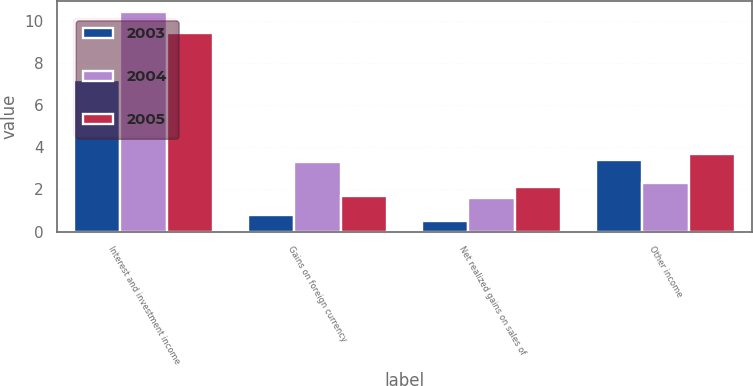Convert chart. <chart><loc_0><loc_0><loc_500><loc_500><stacked_bar_chart><ecel><fcel>Interest and investment income<fcel>Gains on foreign currency<fcel>Net realized gains on sales of<fcel>Other income<nl><fcel>2003<fcel>7.2<fcel>0.8<fcel>0.5<fcel>3.4<nl><fcel>2004<fcel>10.4<fcel>3.3<fcel>1.6<fcel>2.3<nl><fcel>2005<fcel>9.4<fcel>1.7<fcel>2.1<fcel>3.7<nl></chart> 